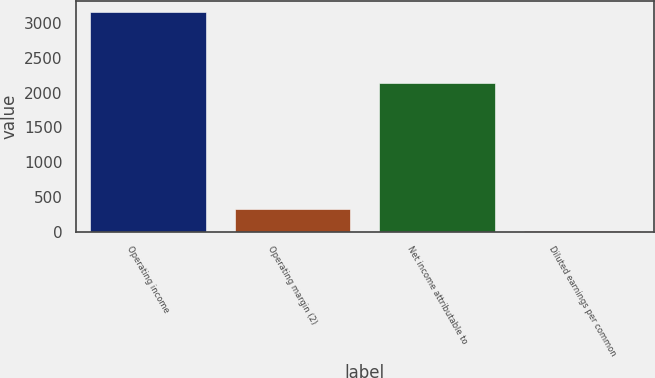Convert chart to OTSL. <chart><loc_0><loc_0><loc_500><loc_500><bar_chart><fcel>Operating income<fcel>Operating margin (2)<fcel>Net income attributable to<fcel>Diluted earnings per common<nl><fcel>3167<fcel>326.55<fcel>2139<fcel>10.94<nl></chart> 